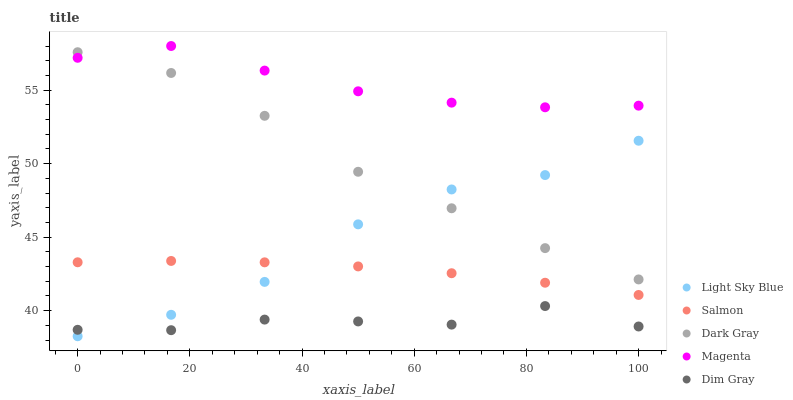Does Dim Gray have the minimum area under the curve?
Answer yes or no. Yes. Does Magenta have the maximum area under the curve?
Answer yes or no. Yes. Does Light Sky Blue have the minimum area under the curve?
Answer yes or no. No. Does Light Sky Blue have the maximum area under the curve?
Answer yes or no. No. Is Salmon the smoothest?
Answer yes or no. Yes. Is Light Sky Blue the roughest?
Answer yes or no. Yes. Is Magenta the smoothest?
Answer yes or no. No. Is Magenta the roughest?
Answer yes or no. No. Does Light Sky Blue have the lowest value?
Answer yes or no. Yes. Does Magenta have the lowest value?
Answer yes or no. No. Does Magenta have the highest value?
Answer yes or no. Yes. Does Light Sky Blue have the highest value?
Answer yes or no. No. Is Dim Gray less than Magenta?
Answer yes or no. Yes. Is Dark Gray greater than Salmon?
Answer yes or no. Yes. Does Dark Gray intersect Magenta?
Answer yes or no. Yes. Is Dark Gray less than Magenta?
Answer yes or no. No. Is Dark Gray greater than Magenta?
Answer yes or no. No. Does Dim Gray intersect Magenta?
Answer yes or no. No. 